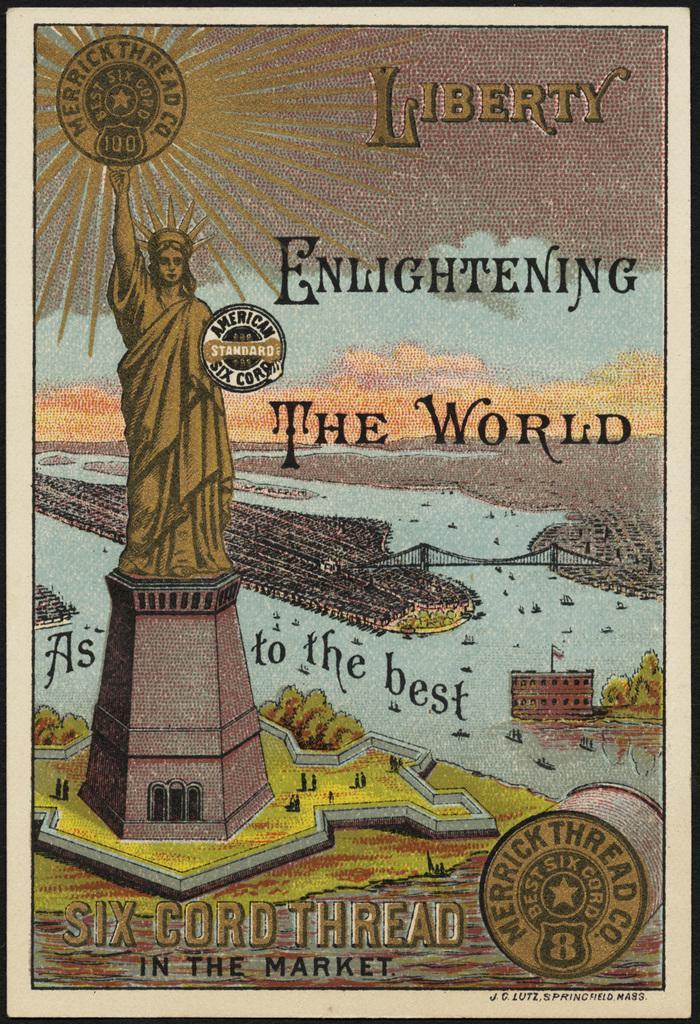Could you give a brief overview of what you see in this image? In this picture there is a poster in the center of the image and there is a statue on the left side of the image. 